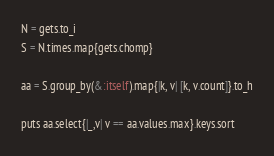Convert code to text. <code><loc_0><loc_0><loc_500><loc_500><_Ruby_>N = gets.to_i
S = N.times.map{gets.chomp}

aa = S.group_by(&:itself).map{|k, v| [k, v.count]}.to_h

puts aa.select{|_,v| v == aa.values.max}.keys.sort</code> 